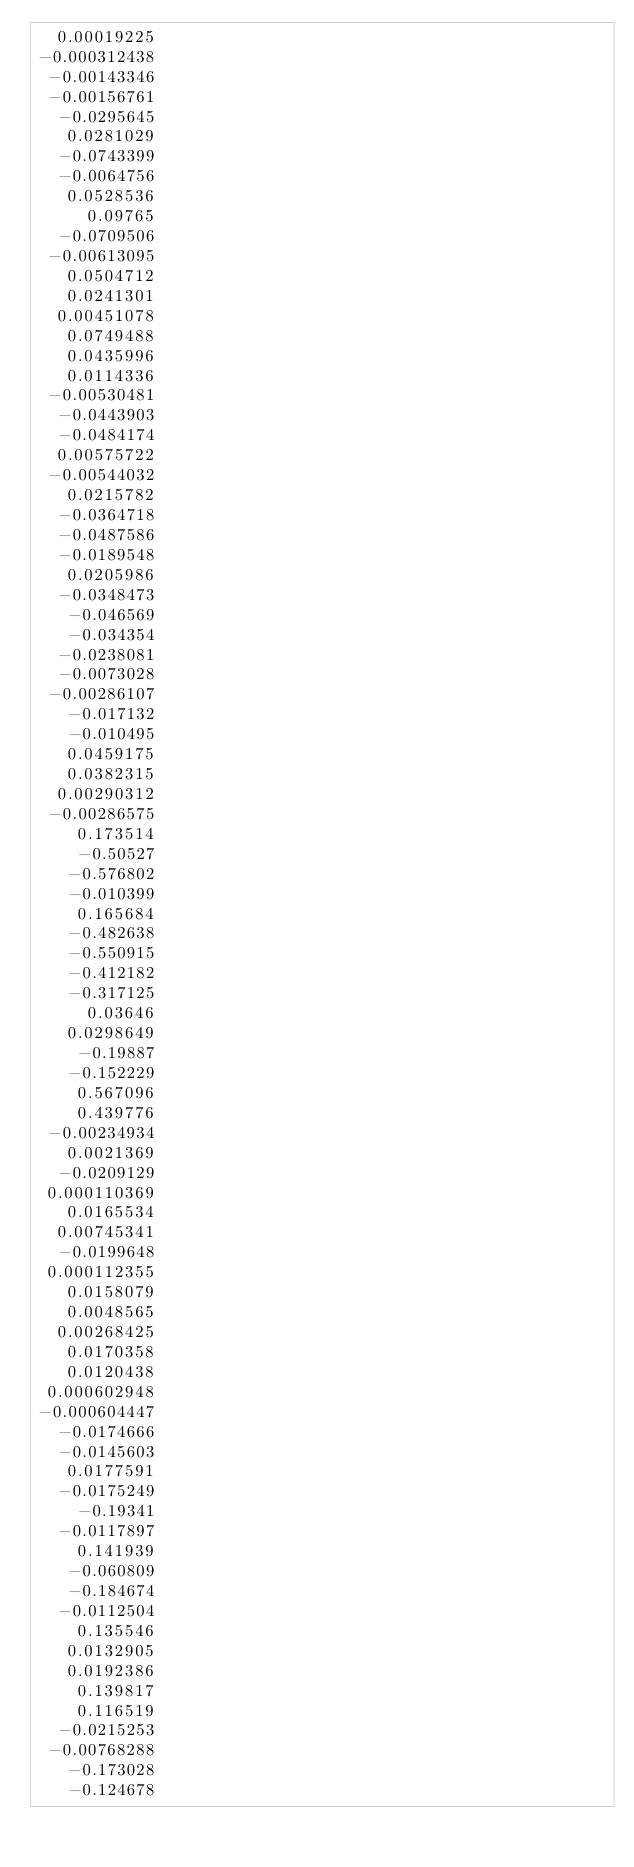Convert code to text. <code><loc_0><loc_0><loc_500><loc_500><_ObjectiveC_>  0.00019225
-0.000312438
 -0.00143346
 -0.00156761
  -0.0295645
   0.0281029
  -0.0743399
  -0.0064756
   0.0528536
     0.09765
  -0.0709506
 -0.00613095
   0.0504712
   0.0241301
  0.00451078
   0.0749488
   0.0435996
   0.0114336
 -0.00530481
  -0.0443903
  -0.0484174
  0.00575722
 -0.00544032
   0.0215782
  -0.0364718
  -0.0487586
  -0.0189548
   0.0205986
  -0.0348473
   -0.046569
   -0.034354
  -0.0238081
  -0.0073028
 -0.00286107
   -0.017132
   -0.010495
   0.0459175
   0.0382315
  0.00290312
 -0.00286575
    0.173514
    -0.50527
   -0.576802
   -0.010399
    0.165684
   -0.482638
   -0.550915
   -0.412182
   -0.317125
     0.03646
   0.0298649
    -0.19887
   -0.152229
    0.567096
    0.439776
 -0.00234934
   0.0021369
  -0.0209129
 0.000110369
   0.0165534
  0.00745341
  -0.0199648
 0.000112355
   0.0158079
   0.0048565
  0.00268425
   0.0170358
   0.0120438
 0.000602948
-0.000604447
  -0.0174666
  -0.0145603
   0.0177591
  -0.0175249
    -0.19341
  -0.0117897
    0.141939
   -0.060809
   -0.184674
  -0.0112504
    0.135546
   0.0132905
   0.0192386
    0.139817
    0.116519
  -0.0215253
 -0.00768288
   -0.173028
   -0.124678</code> 